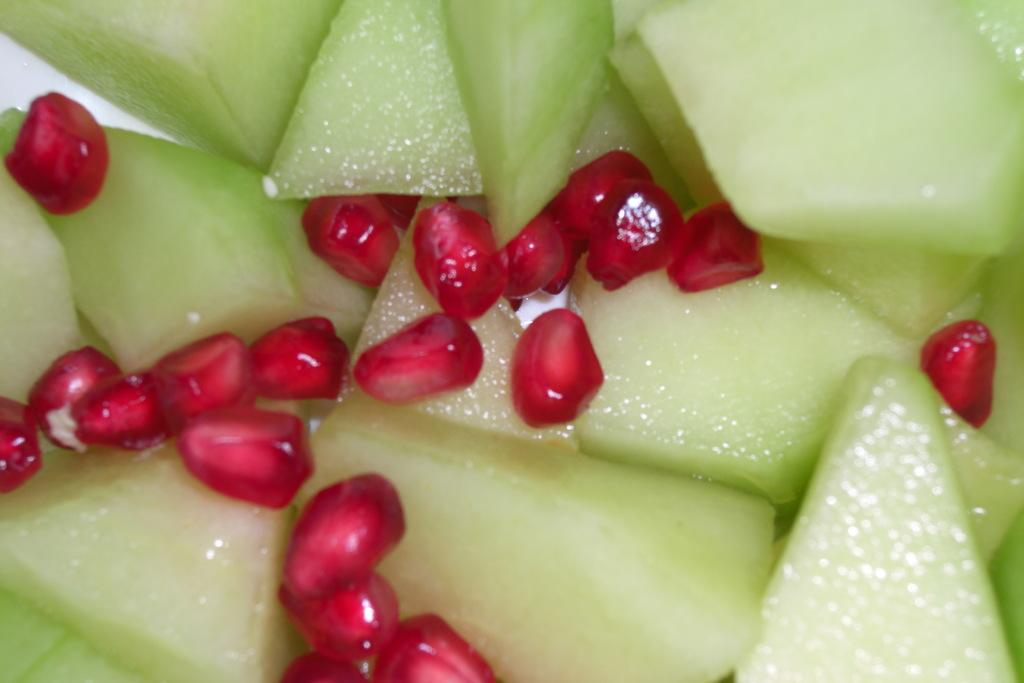What type of fruit is featured in the image? The image contains pomegranate grains. What color are the pomegranate grains? The pomegranate grains are red in color. Are there any other types of fruit in the image besides pomegranate? Yes, there are other fruit pieces in the image. What type of mine is visible in the image? There is no mine present in the image; it features pomegranate grains and other fruit pieces. What type of jam is being made from the pomegranate grains in the image? There is no jam-making process depicted in the image; it simply shows pomegranate grains and other fruit pieces. 